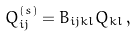Convert formula to latex. <formula><loc_0><loc_0><loc_500><loc_500>Q ^ { ( s ) } _ { i j } = B _ { i j k l } Q _ { k l } \, ,</formula> 